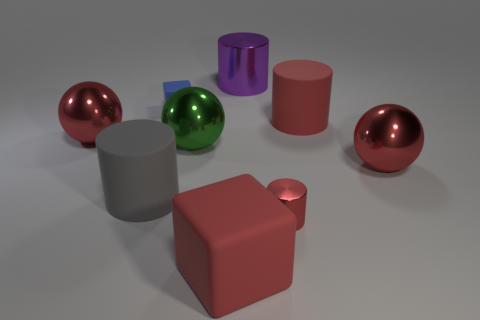Subtract all small red cylinders. How many cylinders are left? 3 Subtract 1 cubes. How many cubes are left? 1 Subtract all green spheres. How many spheres are left? 2 Subtract all purple blocks. How many gray cylinders are left? 1 Subtract all small cylinders. Subtract all red balls. How many objects are left? 6 Add 3 large purple metallic things. How many large purple metallic things are left? 4 Add 9 tiny cyan shiny blocks. How many tiny cyan shiny blocks exist? 9 Subtract 1 blue blocks. How many objects are left? 8 Subtract all cubes. How many objects are left? 7 Subtract all purple cylinders. Subtract all purple spheres. How many cylinders are left? 3 